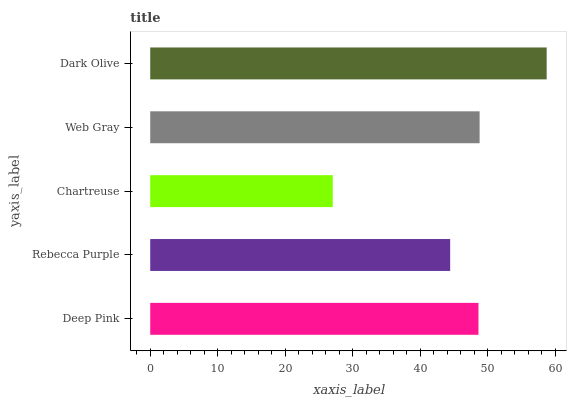Is Chartreuse the minimum?
Answer yes or no. Yes. Is Dark Olive the maximum?
Answer yes or no. Yes. Is Rebecca Purple the minimum?
Answer yes or no. No. Is Rebecca Purple the maximum?
Answer yes or no. No. Is Deep Pink greater than Rebecca Purple?
Answer yes or no. Yes. Is Rebecca Purple less than Deep Pink?
Answer yes or no. Yes. Is Rebecca Purple greater than Deep Pink?
Answer yes or no. No. Is Deep Pink less than Rebecca Purple?
Answer yes or no. No. Is Deep Pink the high median?
Answer yes or no. Yes. Is Deep Pink the low median?
Answer yes or no. Yes. Is Web Gray the high median?
Answer yes or no. No. Is Dark Olive the low median?
Answer yes or no. No. 